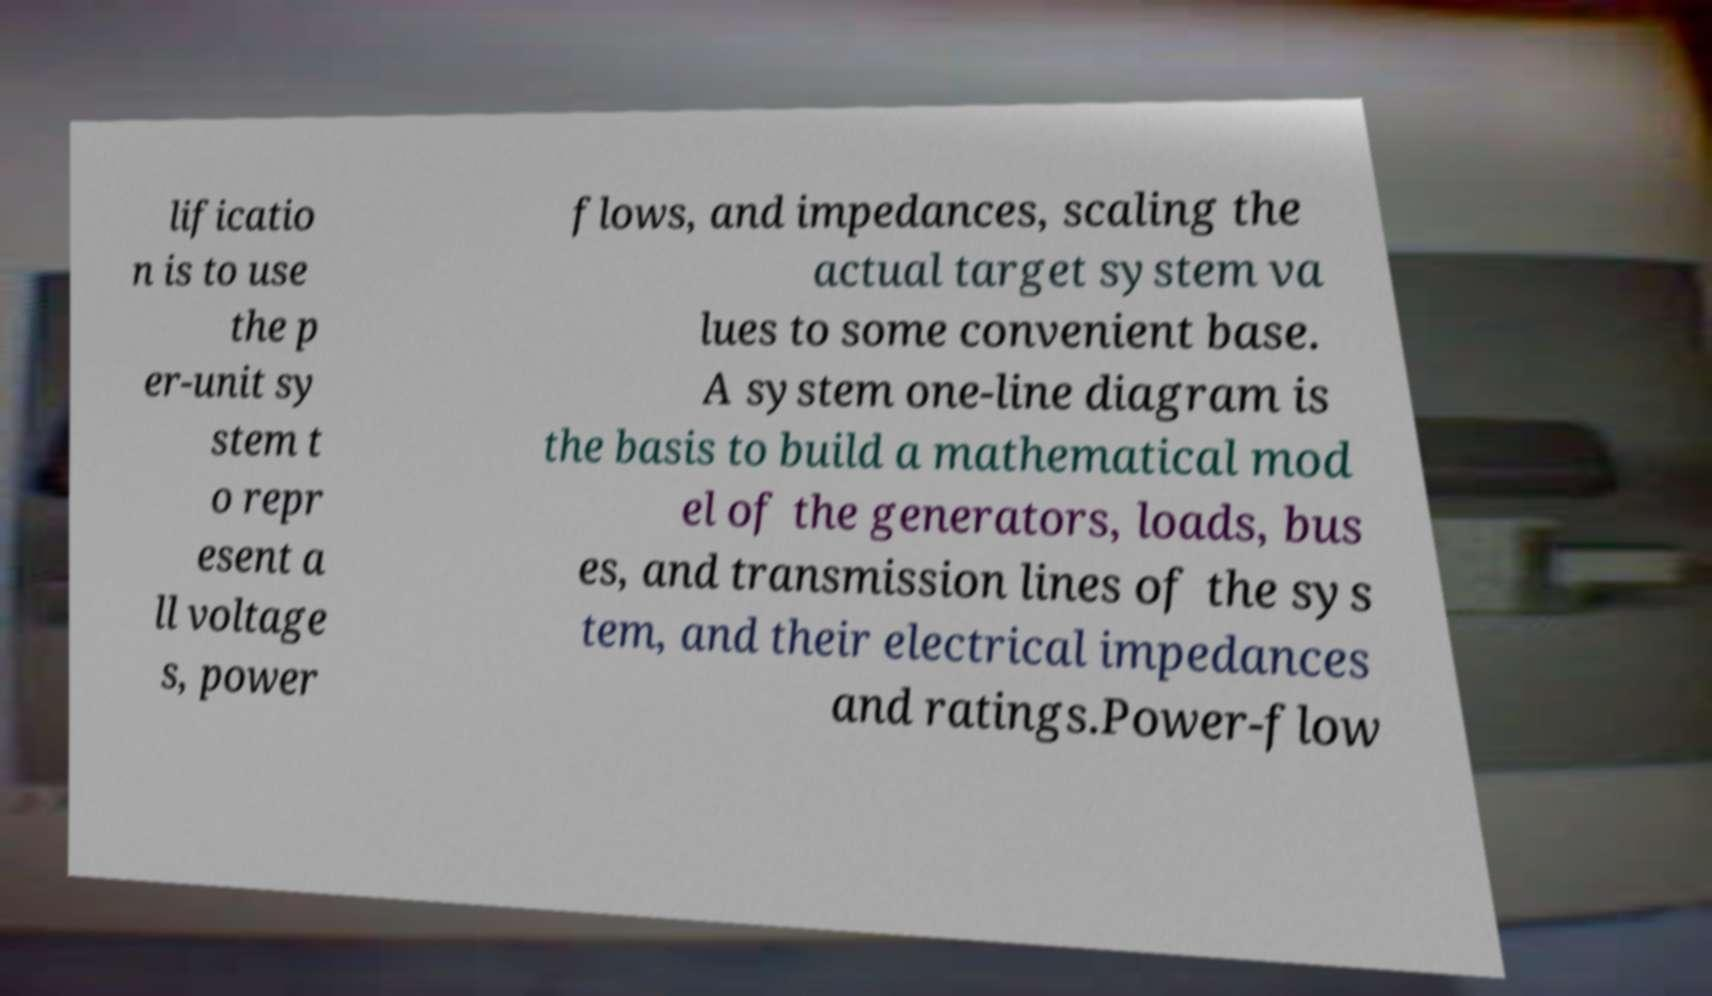What messages or text are displayed in this image? I need them in a readable, typed format. lificatio n is to use the p er-unit sy stem t o repr esent a ll voltage s, power flows, and impedances, scaling the actual target system va lues to some convenient base. A system one-line diagram is the basis to build a mathematical mod el of the generators, loads, bus es, and transmission lines of the sys tem, and their electrical impedances and ratings.Power-flow 